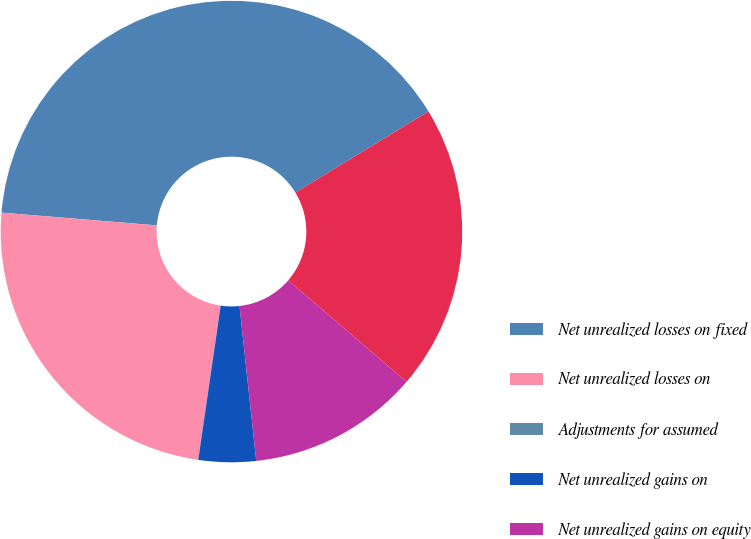Convert chart. <chart><loc_0><loc_0><loc_500><loc_500><pie_chart><fcel>Net unrealized losses on fixed<fcel>Net unrealized losses on<fcel>Adjustments for assumed<fcel>Net unrealized gains on<fcel>Net unrealized gains on equity<fcel>Provision for deferred income<nl><fcel>39.98%<fcel>23.99%<fcel>0.02%<fcel>4.01%<fcel>12.0%<fcel>20.0%<nl></chart> 